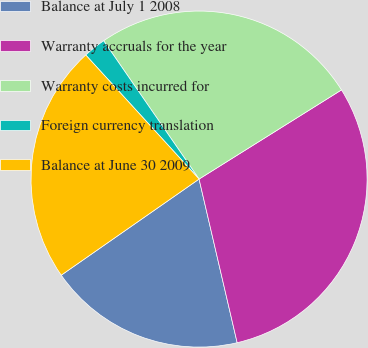Convert chart to OTSL. <chart><loc_0><loc_0><loc_500><loc_500><pie_chart><fcel>Balance at July 1 2008<fcel>Warranty accruals for the year<fcel>Warranty costs incurred for<fcel>Foreign currency translation<fcel>Balance at June 30 2009<nl><fcel>18.95%<fcel>30.26%<fcel>25.71%<fcel>2.17%<fcel>22.91%<nl></chart> 